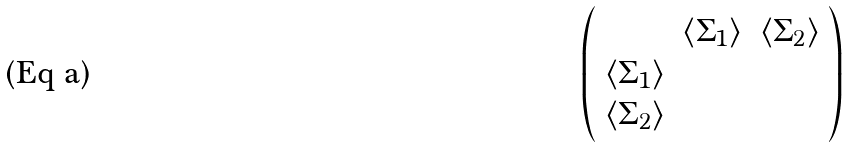<formula> <loc_0><loc_0><loc_500><loc_500>\left ( \begin{array} { c c c } & \langle \Sigma _ { 1 } \rangle & \langle \Sigma _ { 2 } \rangle \\ \langle \Sigma _ { 1 } \rangle & & \\ \langle \Sigma _ { 2 } \rangle & & \end{array} \right )</formula> 